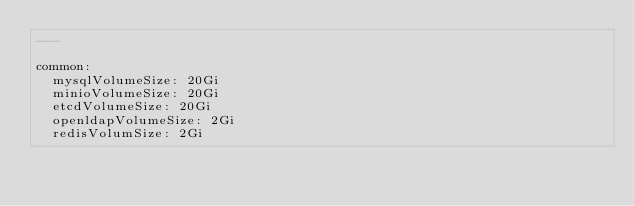<code> <loc_0><loc_0><loc_500><loc_500><_YAML_>---

common:
  mysqlVolumeSize: 20Gi
  minioVolumeSize: 20Gi
  etcdVolumeSize: 20Gi
  openldapVolumeSize: 2Gi
  redisVolumSize: 2Gi</code> 